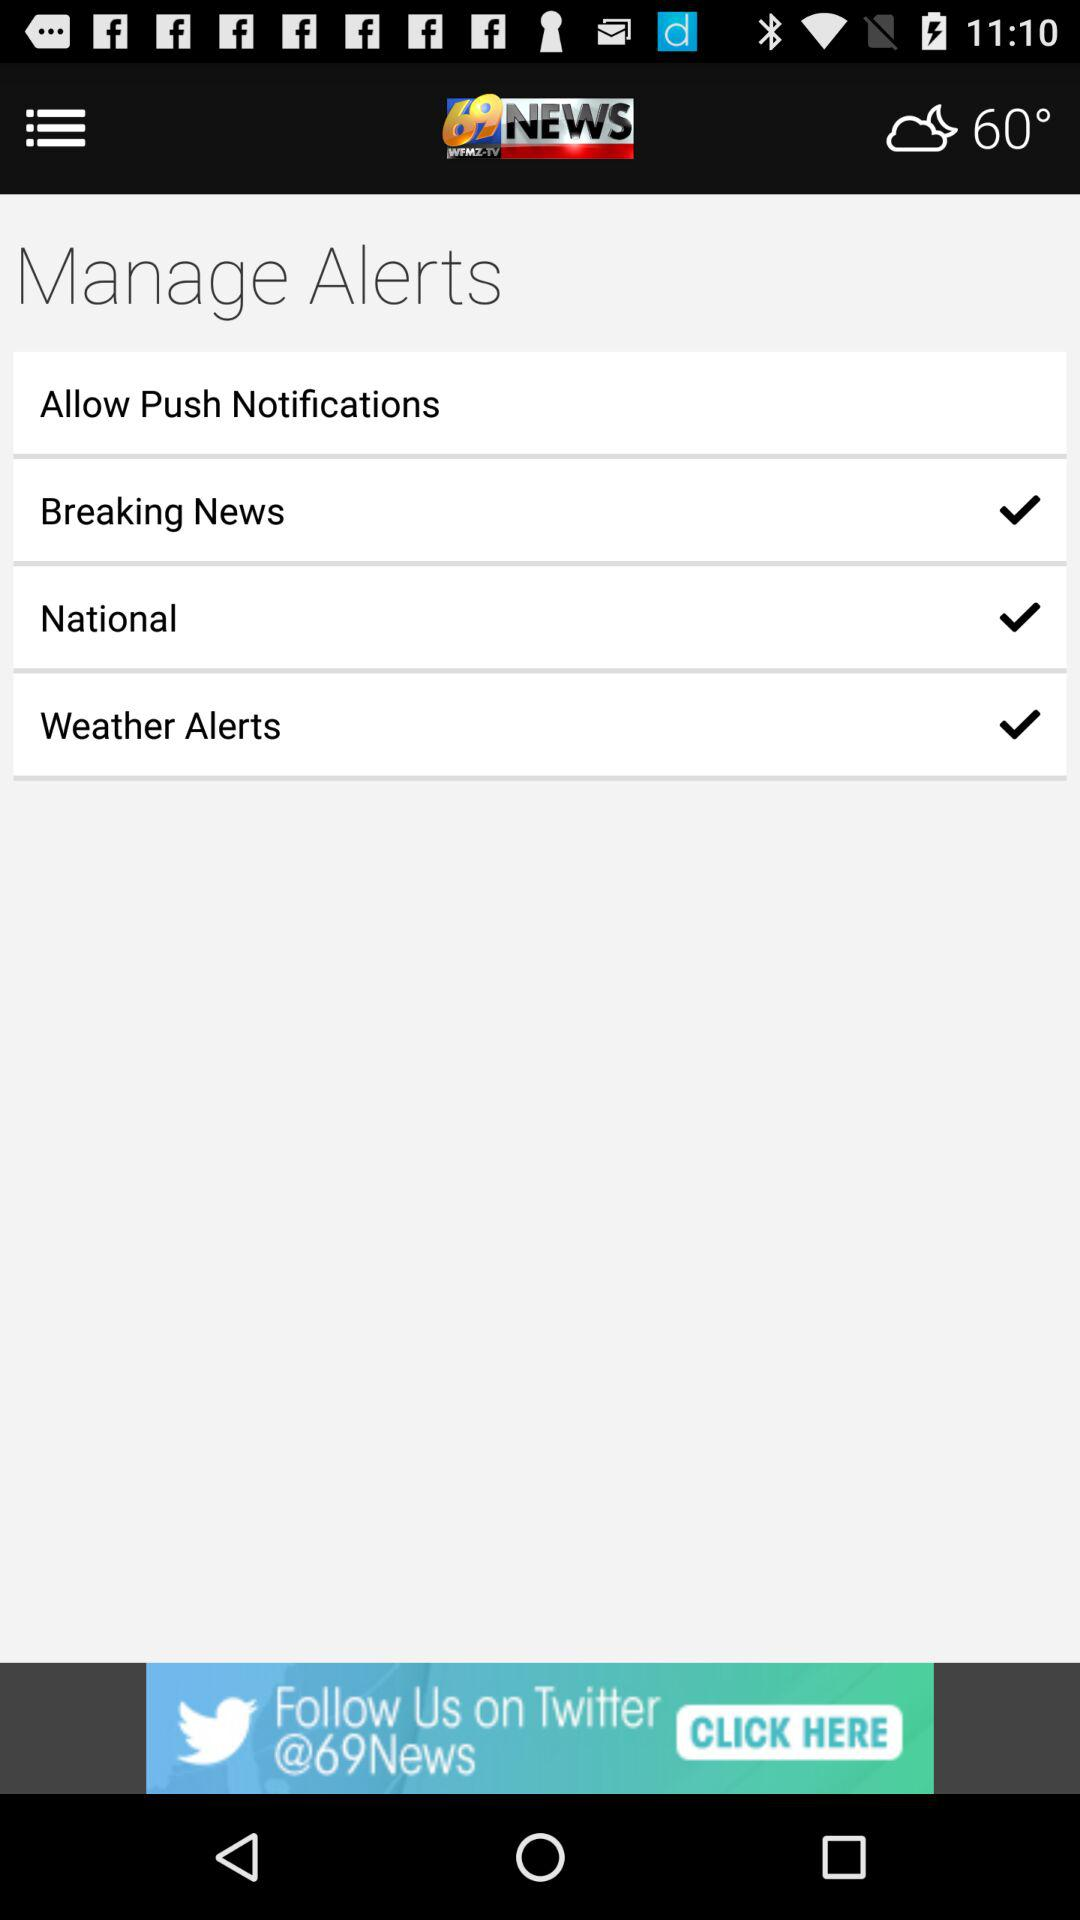Which alerts are enabled? The enabled alerts are "Breaking News", "National" and "Weather Alerts". 